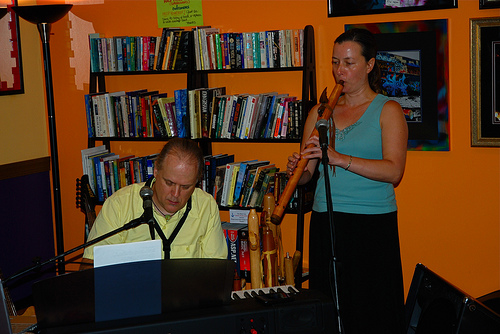<image>
Can you confirm if the book is on the shelf? Yes. Looking at the image, I can see the book is positioned on top of the shelf, with the shelf providing support. Where is the man in relation to the book self? Is it in front of the book self? Yes. The man is positioned in front of the book self, appearing closer to the camera viewpoint. Is the book in front of the man? No. The book is not in front of the man. The spatial positioning shows a different relationship between these objects. 